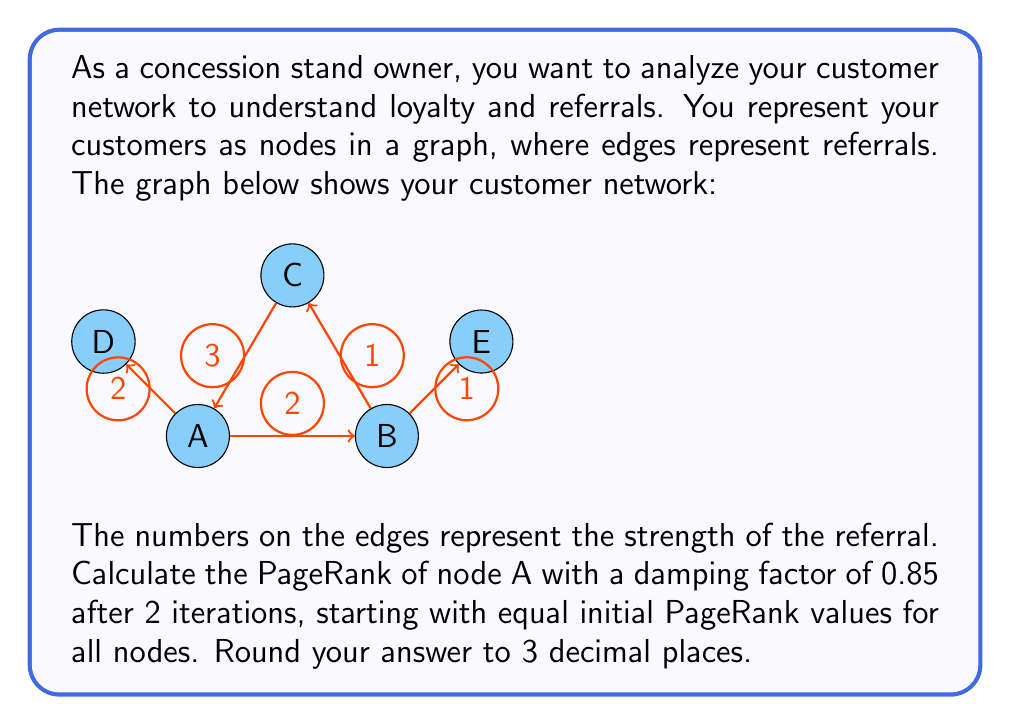Show me your answer to this math problem. To solve this problem, we'll use the PageRank algorithm, which is commonly used in social network analysis to measure the importance of nodes in a graph. Here's how to calculate it step-by-step:

1) First, let's identify the number of nodes: There are 5 nodes (A, B, C, D, E).

2) Initial PageRank values:
   $PR_0(A) = PR_0(B) = PR_0(C) = PR_0(D) = PR_0(E) = \frac{1}{5} = 0.2$

3) PageRank formula:
   $PR(X) = \frac{1-d}{N} + d \sum_{Y \in In(X)} \frac{PR(Y)}{Out(Y)}$
   Where:
   - $d$ is the damping factor (0.85 in this case)
   - $N$ is the total number of nodes (5)
   - $In(X)$ is the set of nodes that link to X
   - $Out(Y)$ is the number of outgoing links from Y

4) First iteration:
   $PR_1(A) = \frac{1-0.85}{5} + 0.85 (\frac{0.2 \cdot 3}{3} + \frac{0.2 \cdot 2}{2})$
   $PR_1(A) = 0.03 + 0.85 (0.2 + 0.2) = 0.37$

5) Second iteration:
   We need to calculate $PR_1$ for C and D to use in $PR_2(A)$:
   
   $PR_1(C) = 0.03 + 0.85 (\frac{0.2 \cdot 1}{2} + \frac{0.2 \cdot 2}{2}) = 0.285$
   $PR_1(D) = 0.03 + 0.85 (\frac{0.2 \cdot 2}{3}) = 0.143$

   Now we can calculate $PR_2(A)$:
   $PR_2(A) = 0.03 + 0.85 (\frac{0.285 \cdot 3}{3} + \frac{0.143 \cdot 2}{2})$
   $PR_2(A) = 0.03 + 0.85 (0.285 + 0.143) = 0.3938$

6) Rounding to 3 decimal places: 0.394
Answer: 0.394 